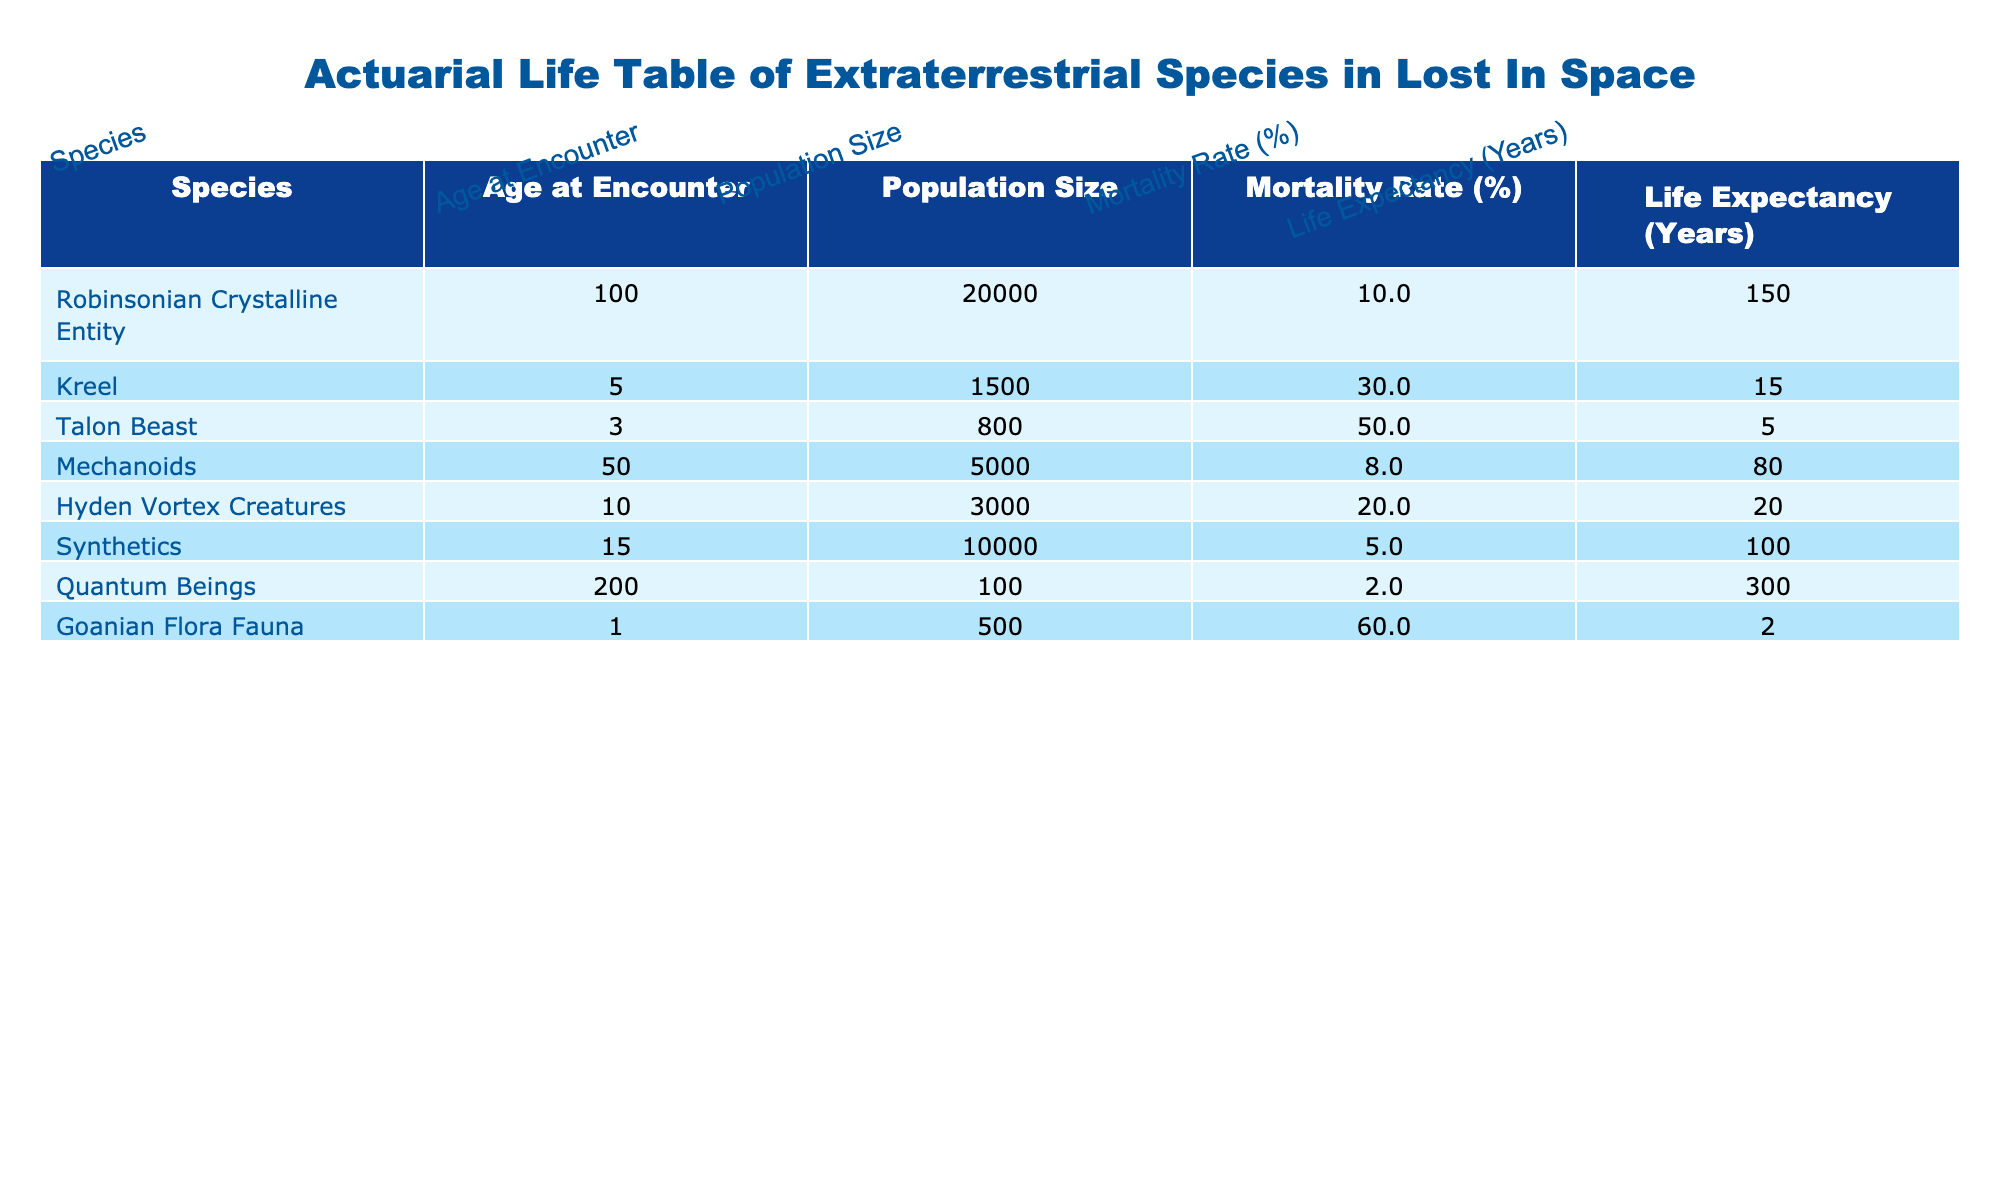What is the mortality rate of the Talon Beast? The table indicates that the Talon Beast has a mortality rate of 50%. This can be found in the column for mortality rates next to the row labeled "Talon Beast."
Answer: 50% Which species has the highest life expectancy? By inspecting the life expectancy column, the Quantum Beings show a life expectancy of 300 years, which is greater than all other species listed.
Answer: 300 What is the average mortality rate of all species listed? To find the average, sum the mortality rates: (10 + 30 + 50 + 8 + 20 + 5 + 2 + 60) = 185. There are 8 species, so the average is 185/8 = 23.125%.
Answer: 23.1 Is the mortality rate of Mechanoids less than that of Hyden Vortex Creatures? The Mechanoids have a mortality rate of 8%, while the Hyden Vortex Creatures have a mortality rate of 20%. Therefore, Mechanoids indeed have a lower mortality rate.
Answer: Yes Which species has the smallest population size among those encountered? Looking at the population size column, the Goanian Flora Fauna has a population size of 500, the lowest among the species listed.
Answer: 500 What is the difference in life expectancy between the Synthetics and the Kreel? The Synthetics have a life expectancy of 100 years and the Kreel have a life expectancy of 15 years. The difference is 100 - 15 = 85 years.
Answer: 85 Are there more than two species with a mortality rate greater than 30%? Checking the mortality rates, the Talon Beast (50%), Kreel (30%), and Goanian Flora Fauna (60%) all exceed 30%. Thus, there are three species that meet this criterion.
Answer: Yes What species has the lowest mortality rate, and what is that rate? The species identified with the lowest mortality rate is the Quantum Beings, having a mortality rate of 2%. This information can be confirmed by scanning the mortality rates column.
Answer: Quantum Beings, 2% 